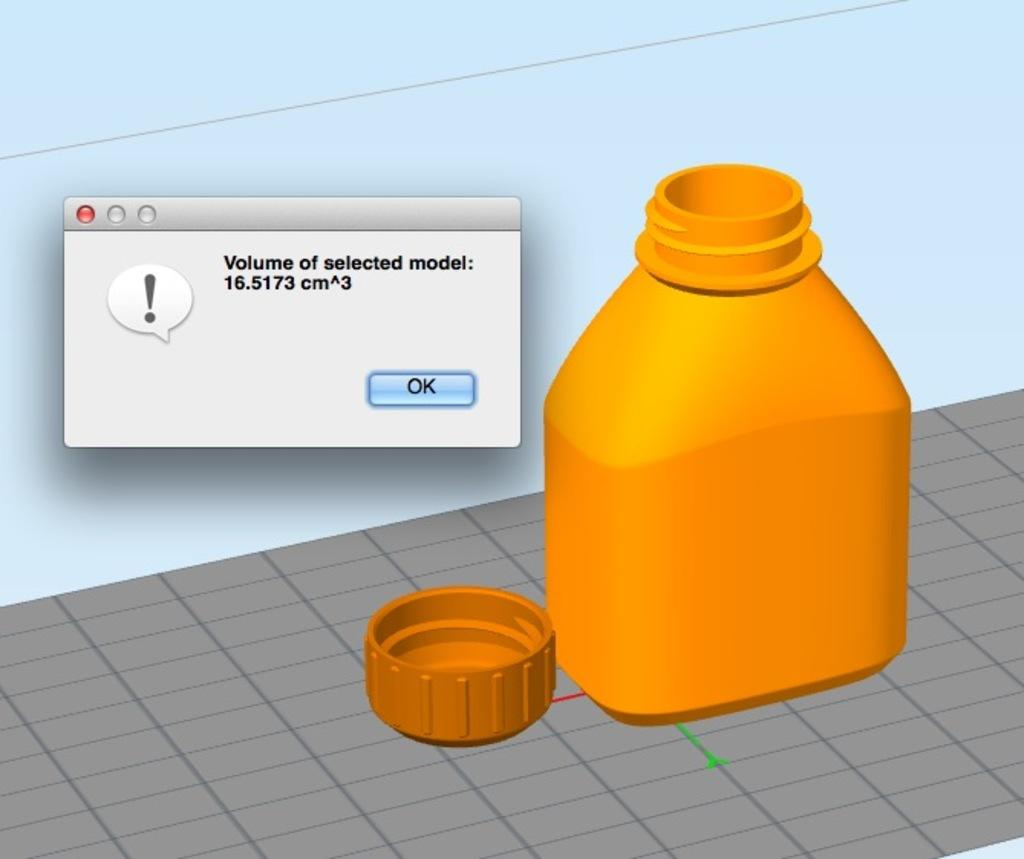Provide a one-sentence caption for the provided image. A computer message that shows the volume of the selected model. 